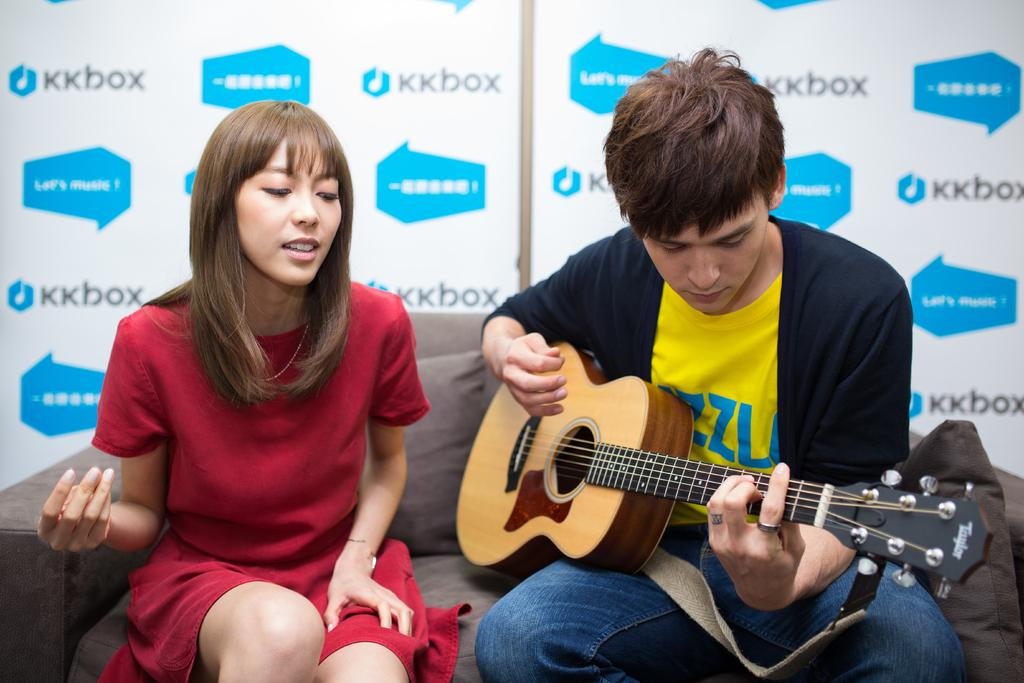How many people are in the image? There are two people in the image, a woman and a man. What are the woman and the man doing in the image? Both the woman and the man are sitting on a couch. What is the man holding in the image? The man is playing a guitar. What is the woman wearing in the image? The woman is wearing a red dress. What is the man wearing in the image? The man is wearing a jacket. What additional object can be seen on the couch? There is a pillow on the couch. What type of tub is visible in the image? There is no tub present in the image. What does the woman feel ashamed about in the image? There is no indication of shame or any negative emotion in the image. 